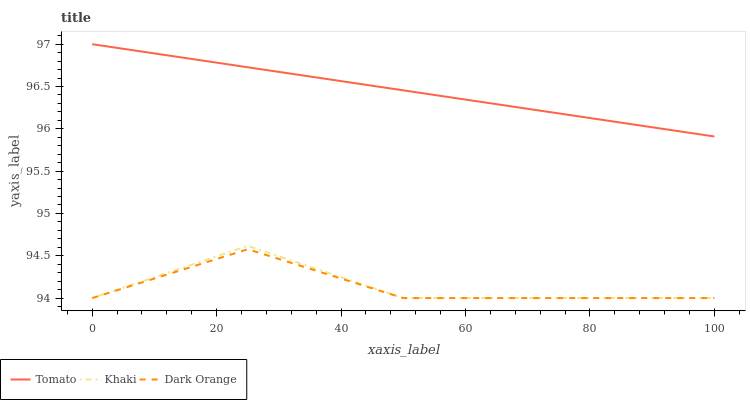Does Dark Orange have the minimum area under the curve?
Answer yes or no. Yes. Does Tomato have the maximum area under the curve?
Answer yes or no. Yes. Does Khaki have the minimum area under the curve?
Answer yes or no. No. Does Khaki have the maximum area under the curve?
Answer yes or no. No. Is Tomato the smoothest?
Answer yes or no. Yes. Is Khaki the roughest?
Answer yes or no. Yes. Is Dark Orange the smoothest?
Answer yes or no. No. Is Dark Orange the roughest?
Answer yes or no. No. Does Dark Orange have the lowest value?
Answer yes or no. Yes. Does Tomato have the highest value?
Answer yes or no. Yes. Does Khaki have the highest value?
Answer yes or no. No. Is Dark Orange less than Tomato?
Answer yes or no. Yes. Is Tomato greater than Khaki?
Answer yes or no. Yes. Does Dark Orange intersect Khaki?
Answer yes or no. Yes. Is Dark Orange less than Khaki?
Answer yes or no. No. Is Dark Orange greater than Khaki?
Answer yes or no. No. Does Dark Orange intersect Tomato?
Answer yes or no. No. 